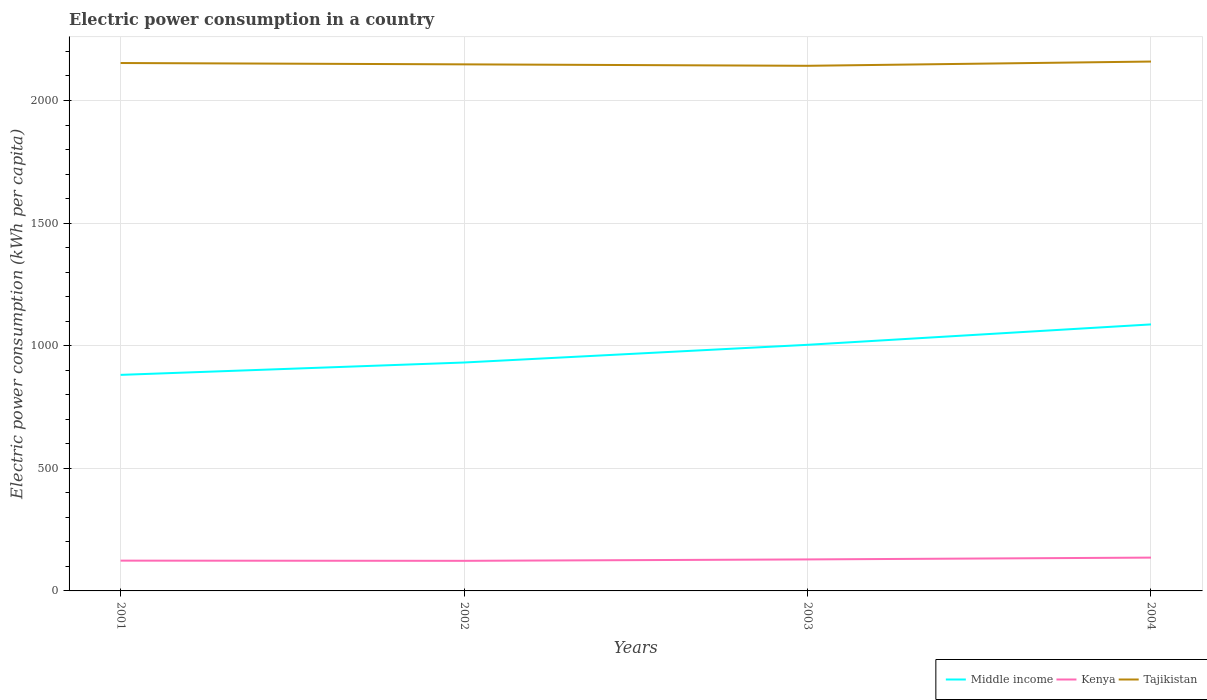Is the number of lines equal to the number of legend labels?
Your answer should be very brief. Yes. Across all years, what is the maximum electric power consumption in in Middle income?
Your answer should be compact. 881.06. In which year was the electric power consumption in in Kenya maximum?
Your answer should be compact. 2002. What is the total electric power consumption in in Middle income in the graph?
Make the answer very short. -122.59. What is the difference between the highest and the second highest electric power consumption in in Middle income?
Your response must be concise. 205.81. What is the difference between the highest and the lowest electric power consumption in in Kenya?
Offer a terse response. 2. Is the electric power consumption in in Kenya strictly greater than the electric power consumption in in Middle income over the years?
Your answer should be very brief. Yes. How many lines are there?
Offer a terse response. 3. Are the values on the major ticks of Y-axis written in scientific E-notation?
Provide a succinct answer. No. Does the graph contain any zero values?
Your answer should be very brief. No. Does the graph contain grids?
Ensure brevity in your answer.  Yes. Where does the legend appear in the graph?
Provide a succinct answer. Bottom right. What is the title of the graph?
Ensure brevity in your answer.  Electric power consumption in a country. Does "Pacific island small states" appear as one of the legend labels in the graph?
Keep it short and to the point. No. What is the label or title of the Y-axis?
Your answer should be compact. Electric power consumption (kWh per capita). What is the Electric power consumption (kWh per capita) of Middle income in 2001?
Offer a terse response. 881.06. What is the Electric power consumption (kWh per capita) of Kenya in 2001?
Your answer should be compact. 123.47. What is the Electric power consumption (kWh per capita) of Tajikistan in 2001?
Provide a succinct answer. 2152.8. What is the Electric power consumption (kWh per capita) of Middle income in 2002?
Ensure brevity in your answer.  931.47. What is the Electric power consumption (kWh per capita) in Kenya in 2002?
Keep it short and to the point. 122.72. What is the Electric power consumption (kWh per capita) of Tajikistan in 2002?
Give a very brief answer. 2147.34. What is the Electric power consumption (kWh per capita) in Middle income in 2003?
Ensure brevity in your answer.  1003.65. What is the Electric power consumption (kWh per capita) of Kenya in 2003?
Keep it short and to the point. 128.46. What is the Electric power consumption (kWh per capita) in Tajikistan in 2003?
Your answer should be very brief. 2141.48. What is the Electric power consumption (kWh per capita) of Middle income in 2004?
Your response must be concise. 1086.87. What is the Electric power consumption (kWh per capita) of Kenya in 2004?
Your response must be concise. 135.87. What is the Electric power consumption (kWh per capita) in Tajikistan in 2004?
Provide a short and direct response. 2158.81. Across all years, what is the maximum Electric power consumption (kWh per capita) in Middle income?
Your answer should be compact. 1086.87. Across all years, what is the maximum Electric power consumption (kWh per capita) of Kenya?
Offer a very short reply. 135.87. Across all years, what is the maximum Electric power consumption (kWh per capita) in Tajikistan?
Provide a succinct answer. 2158.81. Across all years, what is the minimum Electric power consumption (kWh per capita) in Middle income?
Give a very brief answer. 881.06. Across all years, what is the minimum Electric power consumption (kWh per capita) of Kenya?
Give a very brief answer. 122.72. Across all years, what is the minimum Electric power consumption (kWh per capita) of Tajikistan?
Your response must be concise. 2141.48. What is the total Electric power consumption (kWh per capita) of Middle income in the graph?
Your answer should be very brief. 3903.04. What is the total Electric power consumption (kWh per capita) of Kenya in the graph?
Ensure brevity in your answer.  510.52. What is the total Electric power consumption (kWh per capita) in Tajikistan in the graph?
Provide a short and direct response. 8600.43. What is the difference between the Electric power consumption (kWh per capita) of Middle income in 2001 and that in 2002?
Offer a terse response. -50.41. What is the difference between the Electric power consumption (kWh per capita) of Kenya in 2001 and that in 2002?
Offer a terse response. 0.74. What is the difference between the Electric power consumption (kWh per capita) of Tajikistan in 2001 and that in 2002?
Your answer should be compact. 5.46. What is the difference between the Electric power consumption (kWh per capita) in Middle income in 2001 and that in 2003?
Ensure brevity in your answer.  -122.59. What is the difference between the Electric power consumption (kWh per capita) of Kenya in 2001 and that in 2003?
Offer a very short reply. -5. What is the difference between the Electric power consumption (kWh per capita) in Tajikistan in 2001 and that in 2003?
Your answer should be very brief. 11.32. What is the difference between the Electric power consumption (kWh per capita) in Middle income in 2001 and that in 2004?
Offer a very short reply. -205.81. What is the difference between the Electric power consumption (kWh per capita) of Kenya in 2001 and that in 2004?
Keep it short and to the point. -12.4. What is the difference between the Electric power consumption (kWh per capita) in Tajikistan in 2001 and that in 2004?
Provide a succinct answer. -6.01. What is the difference between the Electric power consumption (kWh per capita) in Middle income in 2002 and that in 2003?
Make the answer very short. -72.18. What is the difference between the Electric power consumption (kWh per capita) in Kenya in 2002 and that in 2003?
Provide a succinct answer. -5.74. What is the difference between the Electric power consumption (kWh per capita) of Tajikistan in 2002 and that in 2003?
Your answer should be very brief. 5.87. What is the difference between the Electric power consumption (kWh per capita) of Middle income in 2002 and that in 2004?
Offer a terse response. -155.4. What is the difference between the Electric power consumption (kWh per capita) in Kenya in 2002 and that in 2004?
Your answer should be compact. -13.15. What is the difference between the Electric power consumption (kWh per capita) of Tajikistan in 2002 and that in 2004?
Offer a terse response. -11.47. What is the difference between the Electric power consumption (kWh per capita) of Middle income in 2003 and that in 2004?
Your answer should be very brief. -83.22. What is the difference between the Electric power consumption (kWh per capita) of Kenya in 2003 and that in 2004?
Your response must be concise. -7.41. What is the difference between the Electric power consumption (kWh per capita) in Tajikistan in 2003 and that in 2004?
Your answer should be very brief. -17.33. What is the difference between the Electric power consumption (kWh per capita) in Middle income in 2001 and the Electric power consumption (kWh per capita) in Kenya in 2002?
Your answer should be compact. 758.34. What is the difference between the Electric power consumption (kWh per capita) in Middle income in 2001 and the Electric power consumption (kWh per capita) in Tajikistan in 2002?
Offer a terse response. -1266.28. What is the difference between the Electric power consumption (kWh per capita) in Kenya in 2001 and the Electric power consumption (kWh per capita) in Tajikistan in 2002?
Ensure brevity in your answer.  -2023.88. What is the difference between the Electric power consumption (kWh per capita) of Middle income in 2001 and the Electric power consumption (kWh per capita) of Kenya in 2003?
Ensure brevity in your answer.  752.6. What is the difference between the Electric power consumption (kWh per capita) in Middle income in 2001 and the Electric power consumption (kWh per capita) in Tajikistan in 2003?
Your response must be concise. -1260.42. What is the difference between the Electric power consumption (kWh per capita) of Kenya in 2001 and the Electric power consumption (kWh per capita) of Tajikistan in 2003?
Provide a succinct answer. -2018.01. What is the difference between the Electric power consumption (kWh per capita) in Middle income in 2001 and the Electric power consumption (kWh per capita) in Kenya in 2004?
Your answer should be compact. 745.19. What is the difference between the Electric power consumption (kWh per capita) of Middle income in 2001 and the Electric power consumption (kWh per capita) of Tajikistan in 2004?
Ensure brevity in your answer.  -1277.75. What is the difference between the Electric power consumption (kWh per capita) in Kenya in 2001 and the Electric power consumption (kWh per capita) in Tajikistan in 2004?
Make the answer very short. -2035.35. What is the difference between the Electric power consumption (kWh per capita) of Middle income in 2002 and the Electric power consumption (kWh per capita) of Kenya in 2003?
Give a very brief answer. 803.01. What is the difference between the Electric power consumption (kWh per capita) in Middle income in 2002 and the Electric power consumption (kWh per capita) in Tajikistan in 2003?
Ensure brevity in your answer.  -1210.01. What is the difference between the Electric power consumption (kWh per capita) of Kenya in 2002 and the Electric power consumption (kWh per capita) of Tajikistan in 2003?
Offer a very short reply. -2018.76. What is the difference between the Electric power consumption (kWh per capita) of Middle income in 2002 and the Electric power consumption (kWh per capita) of Kenya in 2004?
Provide a succinct answer. 795.6. What is the difference between the Electric power consumption (kWh per capita) in Middle income in 2002 and the Electric power consumption (kWh per capita) in Tajikistan in 2004?
Your answer should be very brief. -1227.35. What is the difference between the Electric power consumption (kWh per capita) in Kenya in 2002 and the Electric power consumption (kWh per capita) in Tajikistan in 2004?
Make the answer very short. -2036.09. What is the difference between the Electric power consumption (kWh per capita) in Middle income in 2003 and the Electric power consumption (kWh per capita) in Kenya in 2004?
Offer a terse response. 867.78. What is the difference between the Electric power consumption (kWh per capita) of Middle income in 2003 and the Electric power consumption (kWh per capita) of Tajikistan in 2004?
Your answer should be very brief. -1155.17. What is the difference between the Electric power consumption (kWh per capita) in Kenya in 2003 and the Electric power consumption (kWh per capita) in Tajikistan in 2004?
Provide a succinct answer. -2030.35. What is the average Electric power consumption (kWh per capita) in Middle income per year?
Provide a succinct answer. 975.76. What is the average Electric power consumption (kWh per capita) in Kenya per year?
Offer a very short reply. 127.63. What is the average Electric power consumption (kWh per capita) in Tajikistan per year?
Provide a succinct answer. 2150.11. In the year 2001, what is the difference between the Electric power consumption (kWh per capita) in Middle income and Electric power consumption (kWh per capita) in Kenya?
Ensure brevity in your answer.  757.6. In the year 2001, what is the difference between the Electric power consumption (kWh per capita) in Middle income and Electric power consumption (kWh per capita) in Tajikistan?
Offer a very short reply. -1271.74. In the year 2001, what is the difference between the Electric power consumption (kWh per capita) of Kenya and Electric power consumption (kWh per capita) of Tajikistan?
Offer a very short reply. -2029.33. In the year 2002, what is the difference between the Electric power consumption (kWh per capita) of Middle income and Electric power consumption (kWh per capita) of Kenya?
Offer a very short reply. 808.75. In the year 2002, what is the difference between the Electric power consumption (kWh per capita) in Middle income and Electric power consumption (kWh per capita) in Tajikistan?
Offer a very short reply. -1215.88. In the year 2002, what is the difference between the Electric power consumption (kWh per capita) in Kenya and Electric power consumption (kWh per capita) in Tajikistan?
Your answer should be very brief. -2024.62. In the year 2003, what is the difference between the Electric power consumption (kWh per capita) in Middle income and Electric power consumption (kWh per capita) in Kenya?
Offer a terse response. 875.19. In the year 2003, what is the difference between the Electric power consumption (kWh per capita) of Middle income and Electric power consumption (kWh per capita) of Tajikistan?
Provide a short and direct response. -1137.83. In the year 2003, what is the difference between the Electric power consumption (kWh per capita) of Kenya and Electric power consumption (kWh per capita) of Tajikistan?
Ensure brevity in your answer.  -2013.02. In the year 2004, what is the difference between the Electric power consumption (kWh per capita) of Middle income and Electric power consumption (kWh per capita) of Kenya?
Provide a short and direct response. 951. In the year 2004, what is the difference between the Electric power consumption (kWh per capita) of Middle income and Electric power consumption (kWh per capita) of Tajikistan?
Make the answer very short. -1071.94. In the year 2004, what is the difference between the Electric power consumption (kWh per capita) in Kenya and Electric power consumption (kWh per capita) in Tajikistan?
Keep it short and to the point. -2022.94. What is the ratio of the Electric power consumption (kWh per capita) in Middle income in 2001 to that in 2002?
Your response must be concise. 0.95. What is the ratio of the Electric power consumption (kWh per capita) of Middle income in 2001 to that in 2003?
Give a very brief answer. 0.88. What is the ratio of the Electric power consumption (kWh per capita) of Kenya in 2001 to that in 2003?
Your answer should be very brief. 0.96. What is the ratio of the Electric power consumption (kWh per capita) in Tajikistan in 2001 to that in 2003?
Provide a short and direct response. 1.01. What is the ratio of the Electric power consumption (kWh per capita) in Middle income in 2001 to that in 2004?
Offer a terse response. 0.81. What is the ratio of the Electric power consumption (kWh per capita) of Kenya in 2001 to that in 2004?
Your answer should be very brief. 0.91. What is the ratio of the Electric power consumption (kWh per capita) in Middle income in 2002 to that in 2003?
Your answer should be very brief. 0.93. What is the ratio of the Electric power consumption (kWh per capita) of Kenya in 2002 to that in 2003?
Ensure brevity in your answer.  0.96. What is the ratio of the Electric power consumption (kWh per capita) in Middle income in 2002 to that in 2004?
Your answer should be compact. 0.86. What is the ratio of the Electric power consumption (kWh per capita) in Kenya in 2002 to that in 2004?
Keep it short and to the point. 0.9. What is the ratio of the Electric power consumption (kWh per capita) of Middle income in 2003 to that in 2004?
Ensure brevity in your answer.  0.92. What is the ratio of the Electric power consumption (kWh per capita) of Kenya in 2003 to that in 2004?
Offer a very short reply. 0.95. What is the difference between the highest and the second highest Electric power consumption (kWh per capita) of Middle income?
Your answer should be compact. 83.22. What is the difference between the highest and the second highest Electric power consumption (kWh per capita) in Kenya?
Give a very brief answer. 7.41. What is the difference between the highest and the second highest Electric power consumption (kWh per capita) in Tajikistan?
Provide a short and direct response. 6.01. What is the difference between the highest and the lowest Electric power consumption (kWh per capita) in Middle income?
Ensure brevity in your answer.  205.81. What is the difference between the highest and the lowest Electric power consumption (kWh per capita) in Kenya?
Offer a terse response. 13.15. What is the difference between the highest and the lowest Electric power consumption (kWh per capita) of Tajikistan?
Your answer should be very brief. 17.33. 